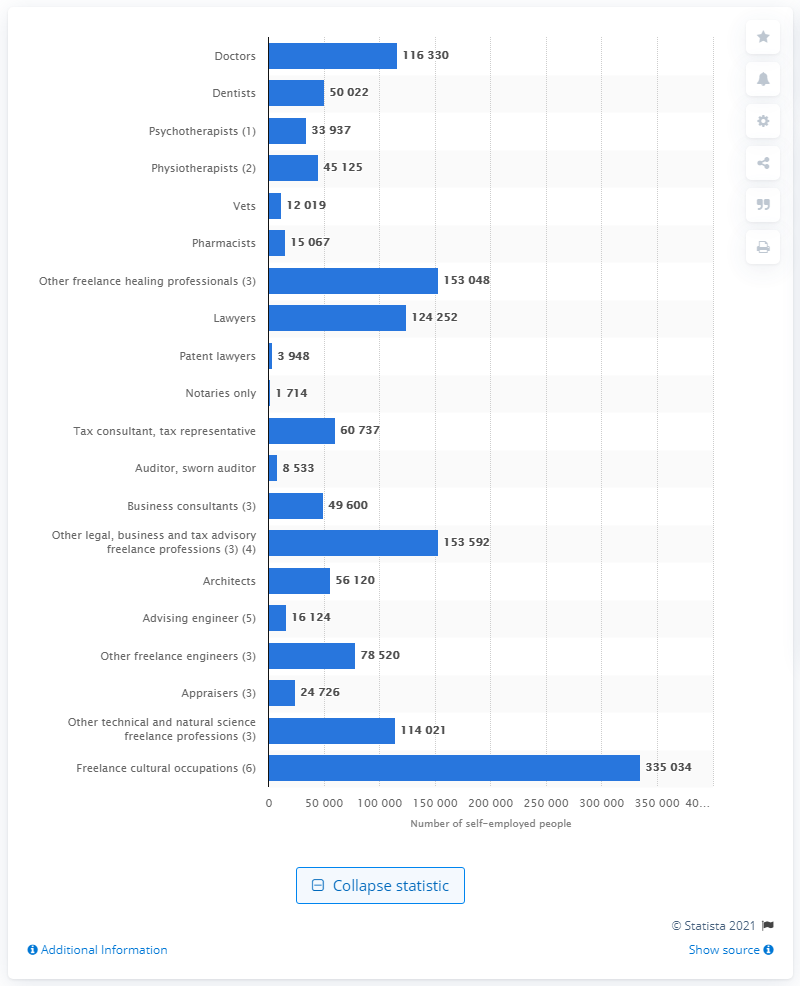Outline some significant characteristics in this image. As of January 2020, there were 124,252 lawyers in Germany. 